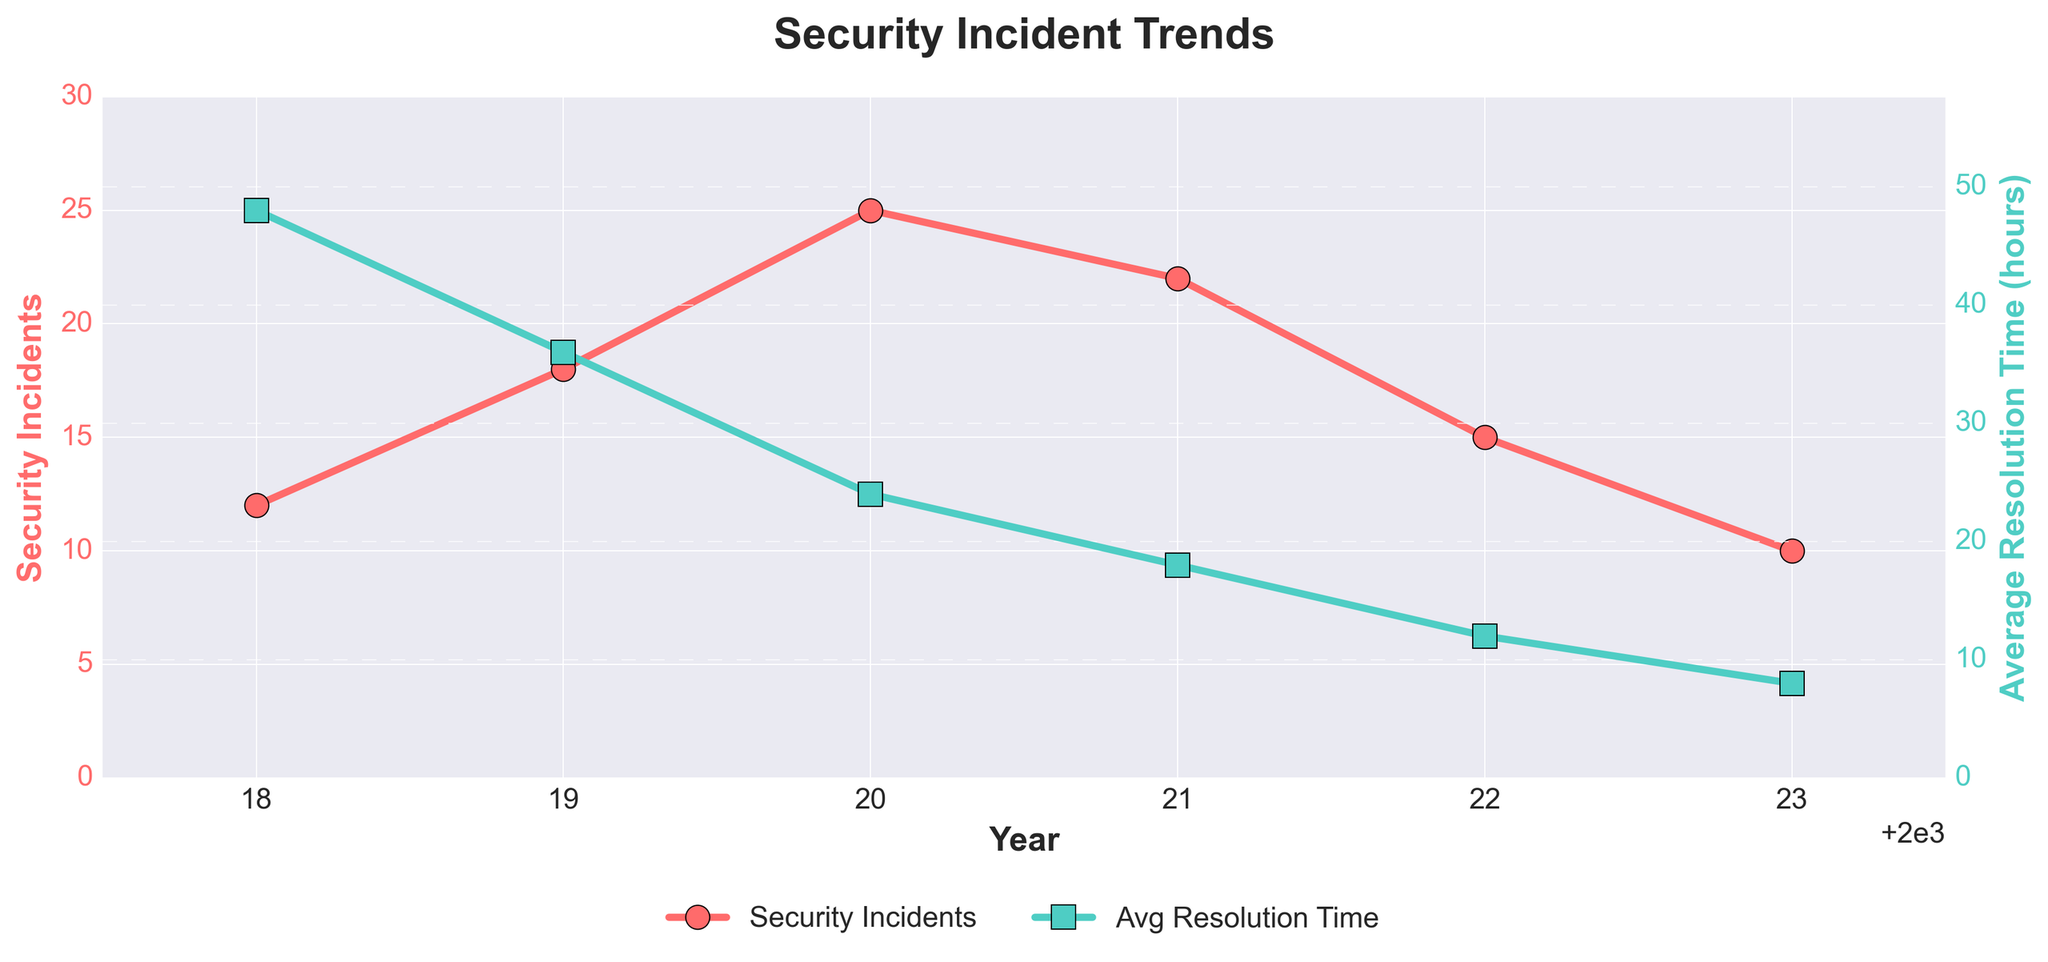What year had the highest number of security incidents? To find the year with the highest number of security incidents, look at the red line representing security incidents and find the peak point. In the chart, 2020 has the highest point on the red line with 25 incidents.
Answer: 2020 How did the average resolution time change from 2018 to 2021? To determine the change in average resolution time from 2018 to 2021, locate these years on the x-axis and compare the heights of the green line. The average resolution time decreased from 48 hours in 2018 to 18 hours in 2021.
Answer: Decreased by 30 hours What is the trend in the number of security incidents from 2020 to 2023? Observe the red line from 2020 to 2023 and see if it is increasing, decreasing, or stable. The number of security incidents decreased from 25 in 2020 to 10 in 2023.
Answer: Decreasing Compare the number of security incidents in 2019 and 2022. Which year had more incidents? Look at the points on the red line for 2019 and 2022. In 2019, there were 18 incidents, and in 2022, there were 15. Thus, 2019 had more incidents.
Answer: 2019 What is the difference in average resolution time between 2019 and 2020? Locate the green line values for 2019 and 2020 and subtract them. The resolution time for 2019 was 36 hours, and for 2020, it was 24 hours. 36 - 24 = 12 hours.
Answer: 12 hours In which year did both the number of security incidents and average resolution time decrease compared to the previous year? Compare the lines from one year to the next. Both security incidents and resolution time decreased from 2019 to 2020 and from 2020 to 2021.
Answer: 2020, 2021 What is the percentage decrease in the number of security incidents from 2020 to 2023? Calculate the percentage decrease using the formula (initial - final) / initial * 100. From 25 incidents in 2020 to 10 in 2023: (25 - 10) / 25 * 100 = 60%.
Answer: 60% Which year had the lowest average resolution time? Look at the green line representing average resolution time and find the lowest point. The lowest point is in 2023 with 8 hours.
Answer: 2023 How did the overall trend in average resolution time change from 2018 to 2023? Look at the green line from 2018 to 2023 and describe the general direction. The average resolution time shows a consistent downward trend from 48 hours in 2018 to 8 hours in 2023.
Answer: Decreasing In which year is the gap between the number of security incidents and average resolution time the smallest? Compare the vertical distances between the red and green lines for each year and find the smallest gap. In 2022, the red line is at 15 and the green line is at 12, creating the smallest gap of 3.
Answer: 2022 